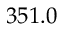<formula> <loc_0><loc_0><loc_500><loc_500>3 5 1 . 0</formula> 